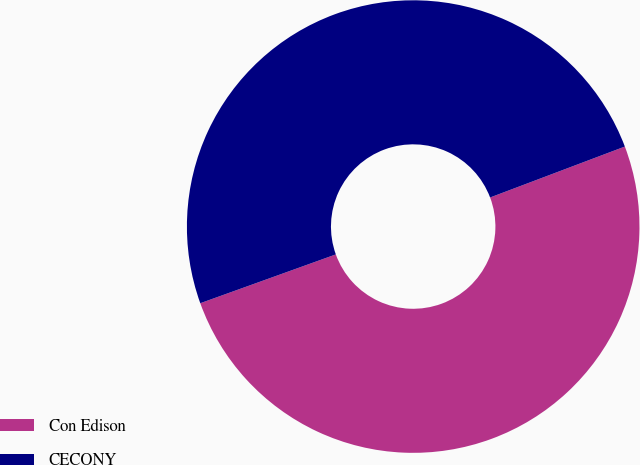Convert chart. <chart><loc_0><loc_0><loc_500><loc_500><pie_chart><fcel>Con Edison<fcel>CECONY<nl><fcel>50.25%<fcel>49.75%<nl></chart> 